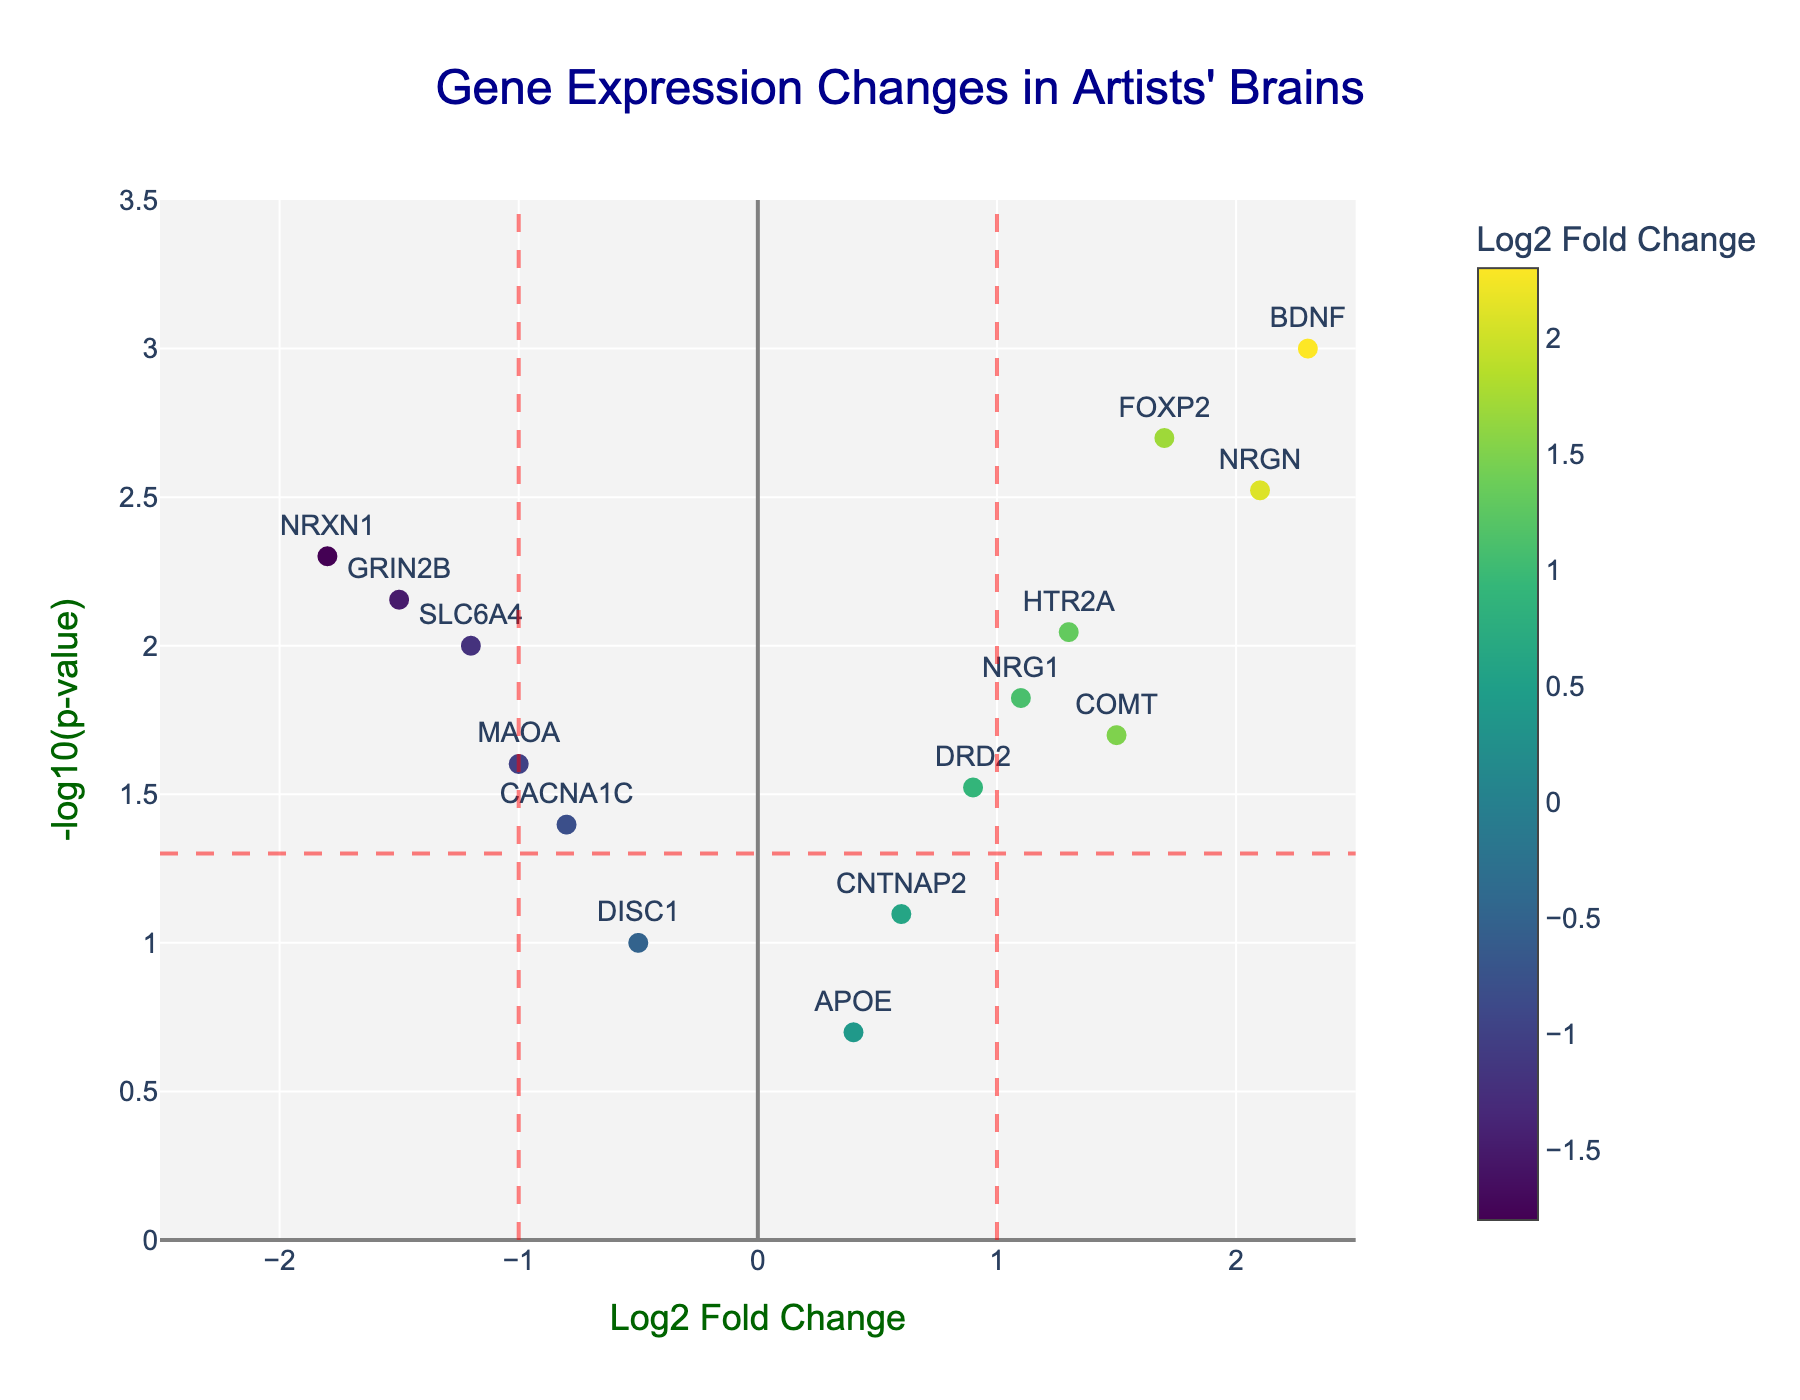How many genes are plotted in the figure? Count the number of markers visible in the plot, each representing a gene.
Answer: 15 Which gene has the highest Log2 Fold Change? Locate the marker farthest to the right along the x-axis (highest positive value). This corresponds to the gene with the highest Log2 Fold Change.
Answer: BDNF What is the p-value for the gene NRGN? Look for the marker labeled "NRGN" and check its y-coordinate; this tells you the -log10(p-value). Convert this back to the p-value by reversing the log transformation: p ≈ 10^-(-log10(p-value)).
Answer: 0.003 How many genes have a Log2 Fold Change greater than 1? Identify markers to the right of the vertical red dashed line at Log2 Fold Change = 1.
Answer: 4 (BDNF, FOXP2, NRG1, NRGN) Which gene with a significant p-value has the smallest Log2 Fold Change? Identify genes above the horizontal red dashed line (-log10(p-value) > -log10(0.05)) and find the one closest to the y-axis (smallest absolute value of Log2 Fold Change).
Answer: CACNA1C Which gene has the lowest p-value? Locate the marker with the highest y-coordinate (highest -log10(p-value)), corresponding to the lowest p-value.
Answer: BDNF Are more genes upregulated or downregulated? Compare the number of markers on the right of the y-axis (positive Log2 Fold Change, upregulated) to the number on the left (negative Log2 Fold Change, downregulated).
Answer: More genes are upregulated Which genes have both a significant p-value and a Log2 Fold Change less than -1? Identify markers that are both below the vertical red dashed line at Log2 Fold Change = -1 and above the horizontal red dashed line.
Answer: NRXN1, GRIN2B What is the color used for genes with negative Log2 Fold Change? Look at the color scale and markers on the left of the y-axis. They are shades in the Viridis color scheme, tending towards green for negative values.
Answer: Green-tinted shades How does the expression of the gene DRD2 compare to that of SLC6A4? Compare the positions of the markers for DRD2 and SLC6A4 along the x-axis and y-axis. DRD2 has Log2 Fold Change of 0.9 and p-value of 0.03, whereas SLC6A4 has Log2 Fold Change of -1.2 and p-value of 0.01.
Answer: DRD2 is upregulated, SLC6A4 is downregulated. DRD2 has less significant p-value 